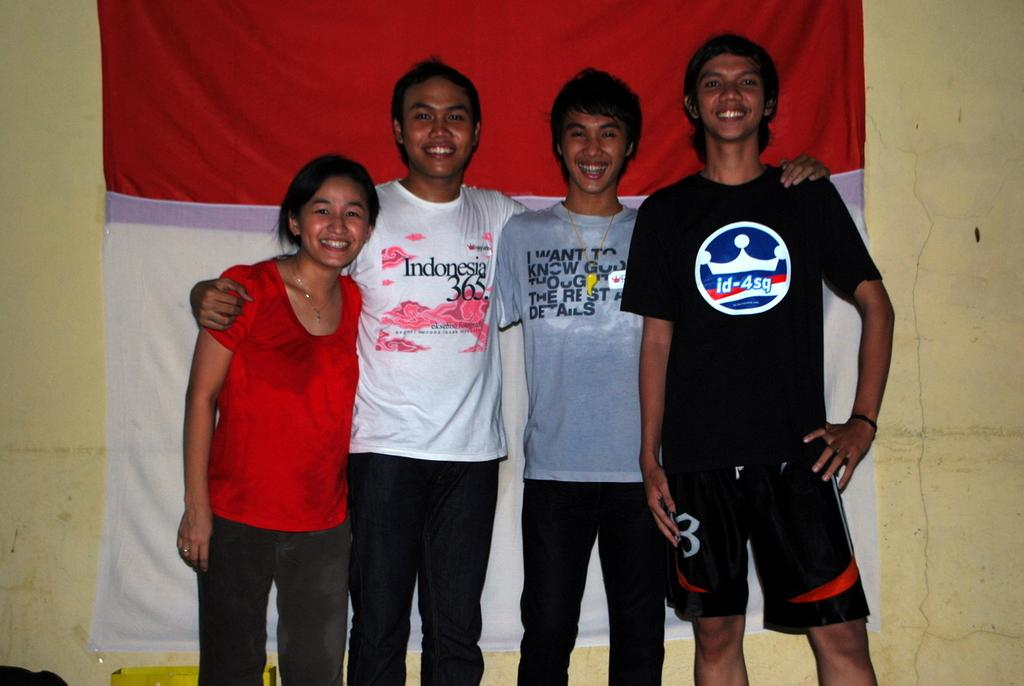<image>
Write a terse but informative summary of the picture. the name Indonesia is on the shirt of the person on the left 